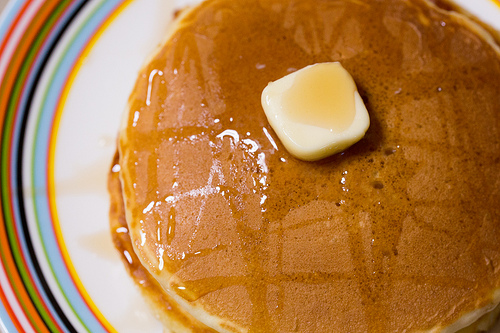<image>
Can you confirm if the cheese is on the cake? Yes. Looking at the image, I can see the cheese is positioned on top of the cake, with the cake providing support. Where is the butter in relation to the pancake? Is it on the pancake? Yes. Looking at the image, I can see the butter is positioned on top of the pancake, with the pancake providing support. 